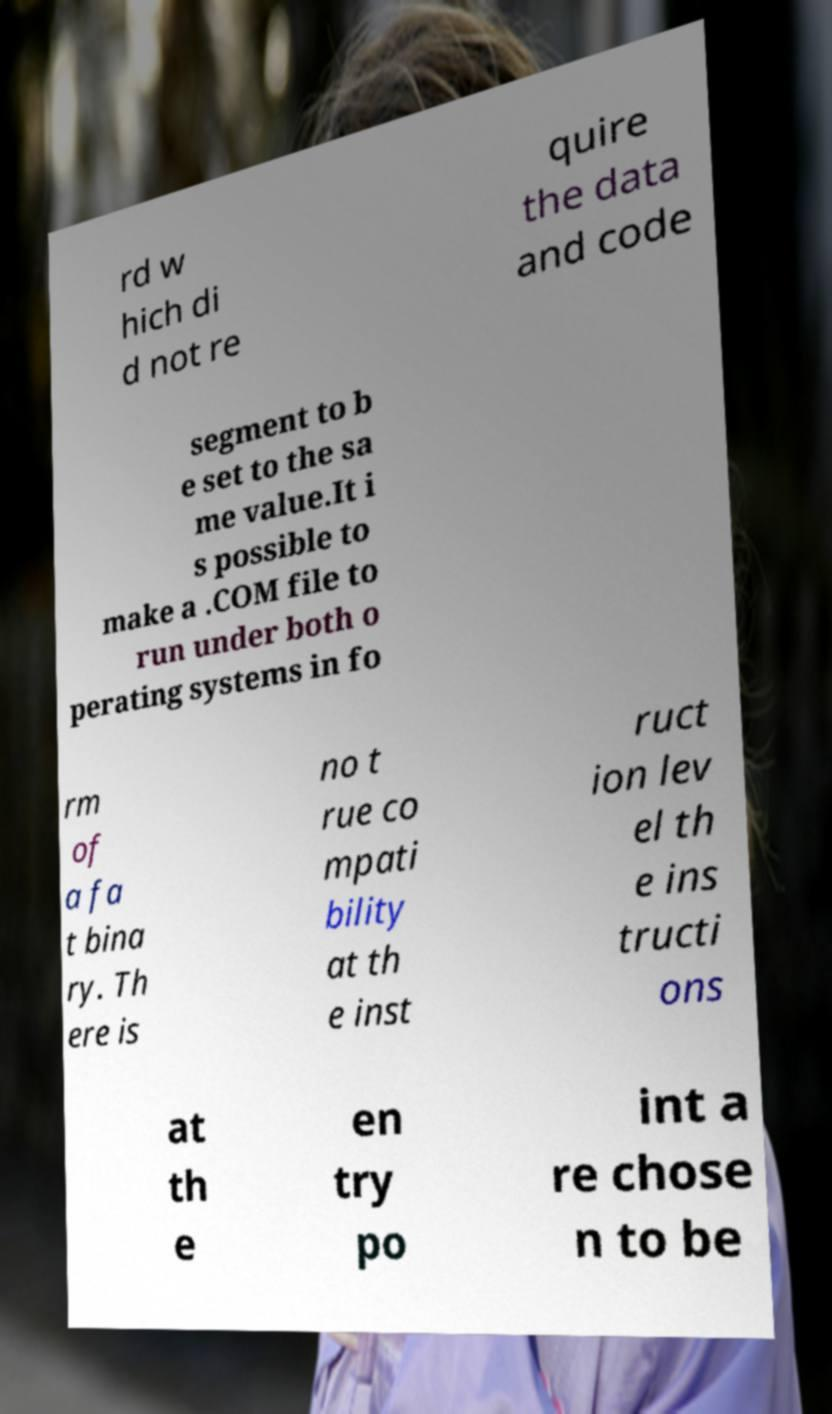Could you extract and type out the text from this image? rd w hich di d not re quire the data and code segment to b e set to the sa me value.It i s possible to make a .COM file to run under both o perating systems in fo rm of a fa t bina ry. Th ere is no t rue co mpati bility at th e inst ruct ion lev el th e ins tructi ons at th e en try po int a re chose n to be 